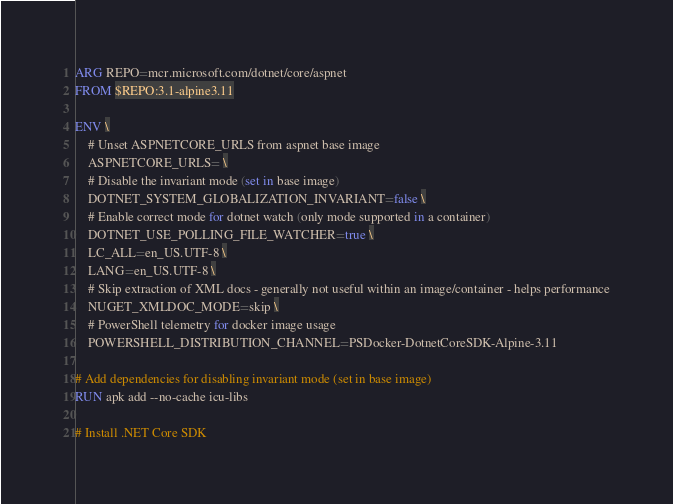Convert code to text. <code><loc_0><loc_0><loc_500><loc_500><_Dockerfile_>ARG REPO=mcr.microsoft.com/dotnet/core/aspnet
FROM $REPO:3.1-alpine3.11

ENV \
    # Unset ASPNETCORE_URLS from aspnet base image
    ASPNETCORE_URLS= \
    # Disable the invariant mode (set in base image)
    DOTNET_SYSTEM_GLOBALIZATION_INVARIANT=false \
    # Enable correct mode for dotnet watch (only mode supported in a container)
    DOTNET_USE_POLLING_FILE_WATCHER=true \
    LC_ALL=en_US.UTF-8 \
    LANG=en_US.UTF-8 \
    # Skip extraction of XML docs - generally not useful within an image/container - helps performance
    NUGET_XMLDOC_MODE=skip \
    # PowerShell telemetry for docker image usage
    POWERSHELL_DISTRIBUTION_CHANNEL=PSDocker-DotnetCoreSDK-Alpine-3.11

# Add dependencies for disabling invariant mode (set in base image)
RUN apk add --no-cache icu-libs

# Install .NET Core SDK</code> 